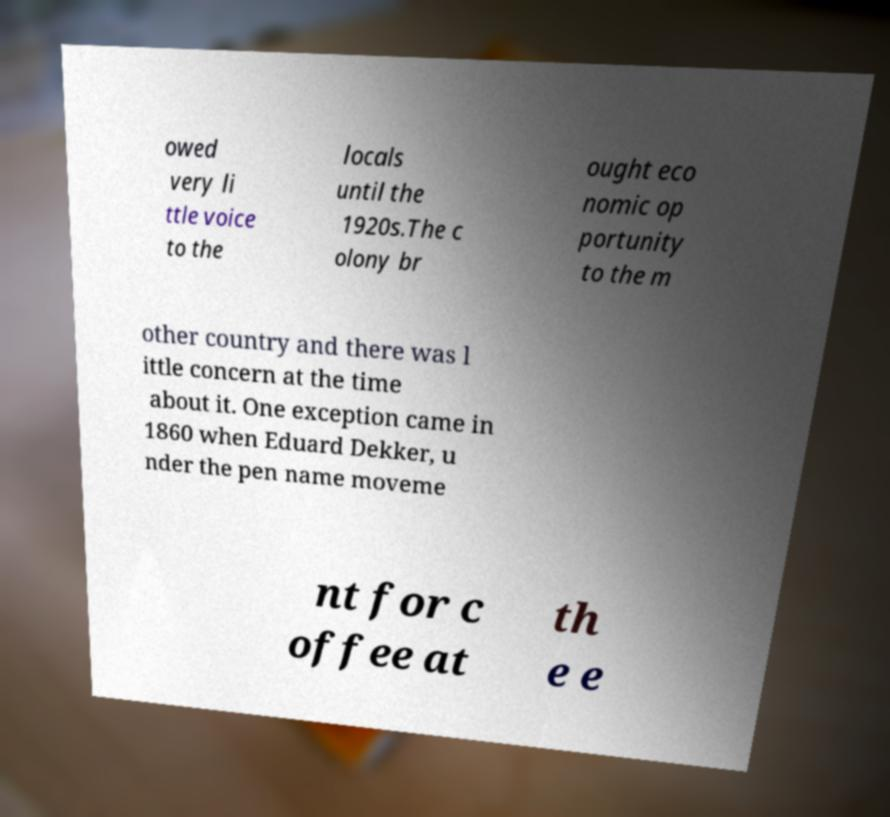For documentation purposes, I need the text within this image transcribed. Could you provide that? owed very li ttle voice to the locals until the 1920s.The c olony br ought eco nomic op portunity to the m other country and there was l ittle concern at the time about it. One exception came in 1860 when Eduard Dekker, u nder the pen name moveme nt for c offee at th e e 